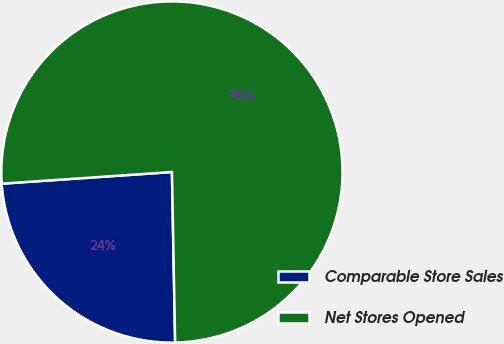Convert chart to OTSL. <chart><loc_0><loc_0><loc_500><loc_500><pie_chart><fcel>Comparable Store Sales<fcel>Net Stores Opened<nl><fcel>24.21%<fcel>75.79%<nl></chart> 